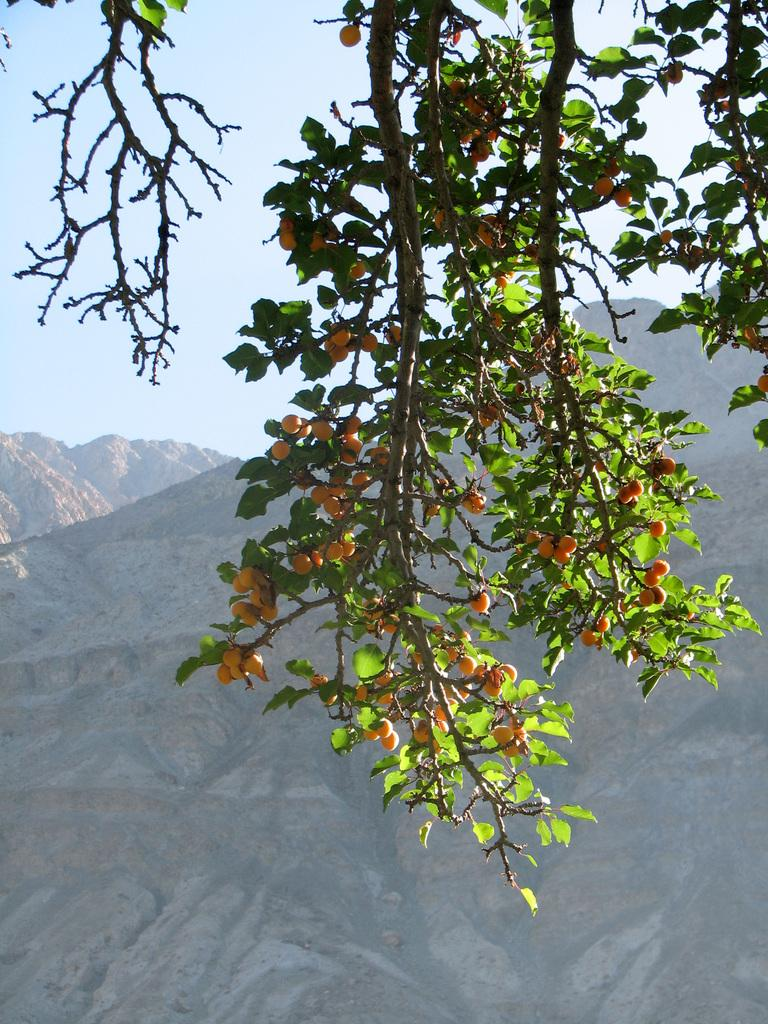What type of vegetation can be seen in the image? There are tree branches and leaves in the image. What is attached to the tree branches? There are orange-colored fruits on the tree branches. What type of geographical feature can be seen in the image? There are mountains visible in the image. What is the color of the sky in the image? The sky is pale blue in the image. What type of ornament is hanging from the tree branches in the image? There is no ornament hanging from the tree branches in the image. Can you see any nails being used in the image? There is no reference to nails in the image. Is there a whistle visible in the image? There is no whistle present in the image. 